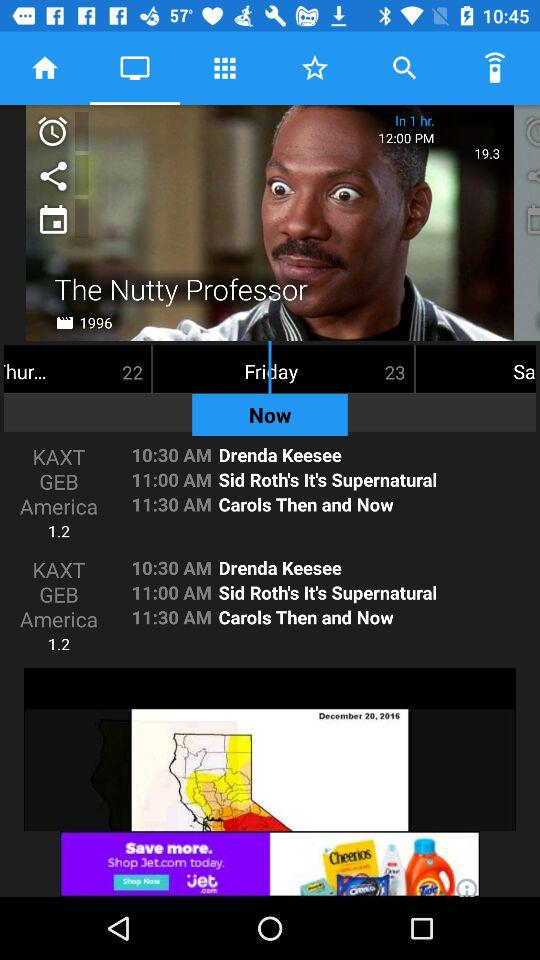When was "The Nutty Professor" released? It was released in 1996. 